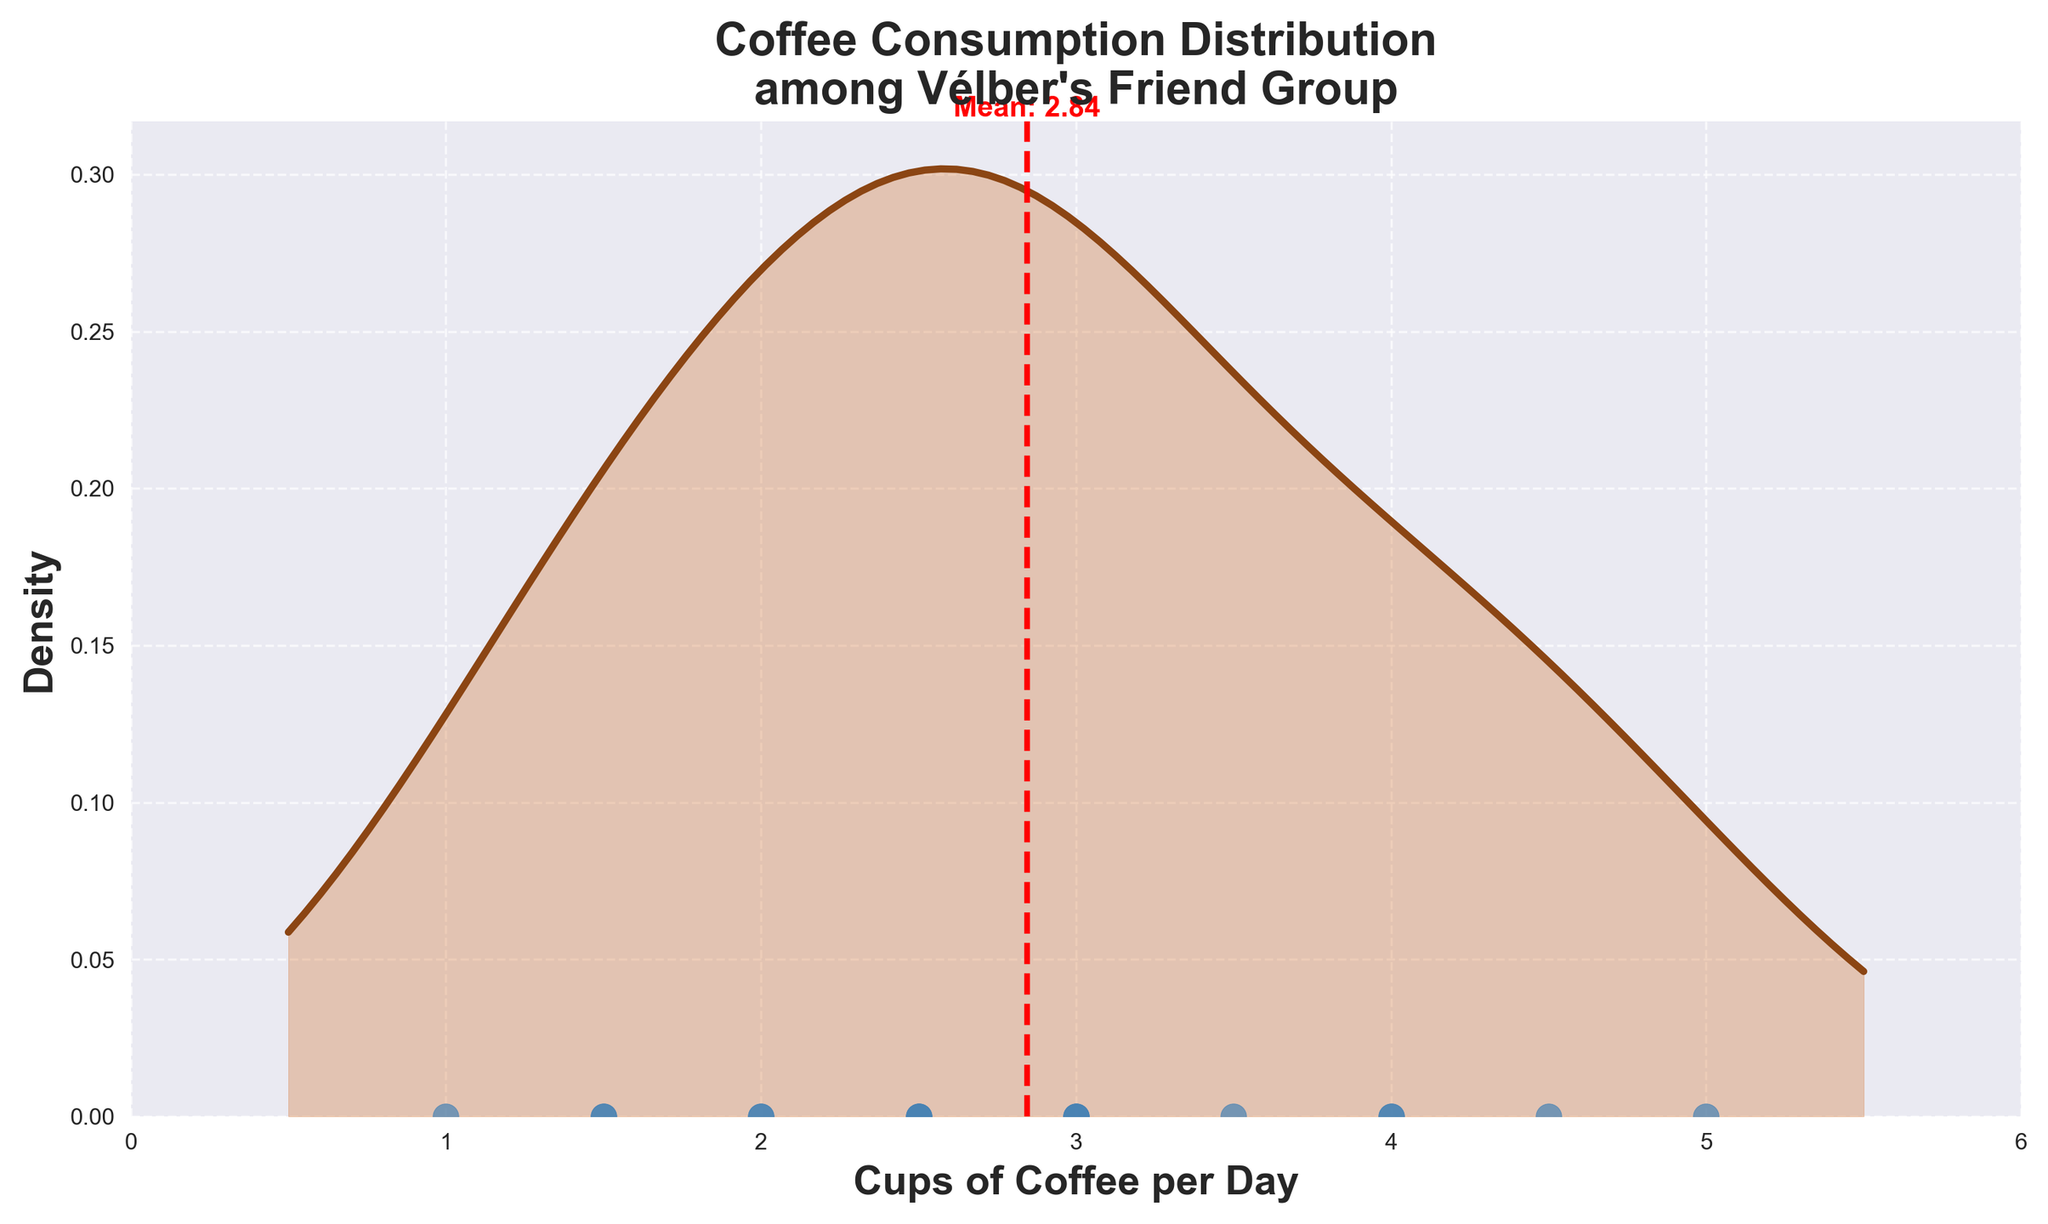What is the title of the plot? The title of the plot can be found at the top of the figure.
Answer: Coffee Consumption Distribution among Vélber's Friend Group How many friends' coffee consumption habits are shown in the plot? Count the number of individual data points (dots) on the x-axis of the plot.
Answer: 16 What is the range of coffee consumption among Vélber's friends? The range can be determined by finding the minimum and maximum values on the x-axis where the data points are plotted.
Answer: 1 to 5 cups per day What is the mean coffee consumption of Vélber's friends? The mean is shown by a vertical dashed line in red, which also has a label indicating the mean value.
Answer: 2.97 cups per day Which friend drinks the most coffee per day? Identify the highest data point on the x-axis, labeled as "Lena".
Answer: Lena How many friends drink more than 3 cups of coffee per day? Count the number of data points that are positioned to the right of the 3 cups per day mark on the x-axis.
Answer: 6 What is the coffee consumption of the friend with the lowest cups per day? Find the lowest data point on the x-axis, which is labeled as "Raj".
Answer: 1 cup per day How does Vélber's coffee consumption compare to the group's mean? Compare the position of Vélber's data point on the x-axis (3 cups per day) with the mean (2.97 cups per day).
Answer: Slightly above the mean Which two friends drink 2.5 cups of coffee per day? Identify the data points on the x-axis labeled at 2.5, which are "You", "Diego", and "Yuki".
Answer: You, Diego, and Yuki Is there a peak in the density distribution? If so, where is it located? To find the peak, observe the highest point in the density curve.
Answer: Around 3 cups per day 